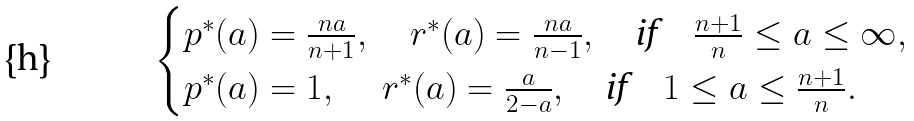<formula> <loc_0><loc_0><loc_500><loc_500>\begin{cases} p ^ { * } ( a ) = \frac { n a } { n + 1 } , \quad r ^ { * } ( a ) = \frac { n a } { n - 1 } , \quad \text {if} \quad \frac { n + 1 } n \leq a \leq \infty , \\ p ^ { * } ( a ) = 1 , \quad \, r ^ { * } ( a ) = \frac { a } { 2 - a } , \quad \text {if} \quad 1 \leq a \leq \frac { n + 1 } n . \end{cases}</formula> 